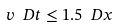<formula> <loc_0><loc_0><loc_500><loc_500>v \ D t \leq 1 . 5 \ D x</formula> 